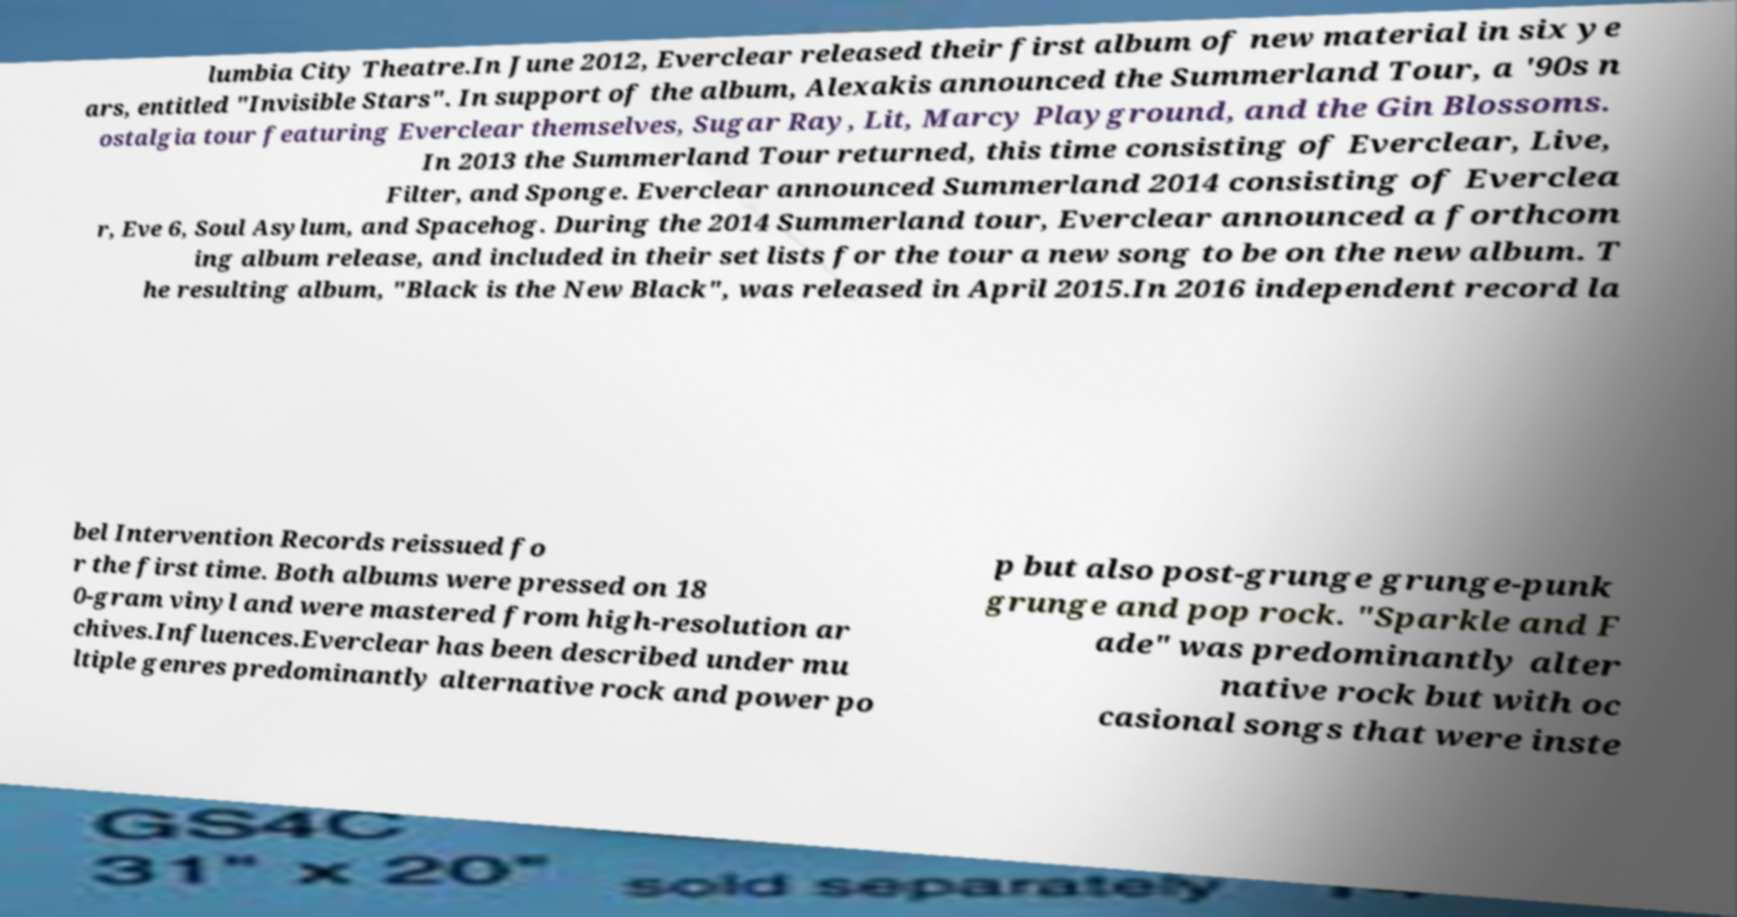For documentation purposes, I need the text within this image transcribed. Could you provide that? lumbia City Theatre.In June 2012, Everclear released their first album of new material in six ye ars, entitled "Invisible Stars". In support of the album, Alexakis announced the Summerland Tour, a '90s n ostalgia tour featuring Everclear themselves, Sugar Ray, Lit, Marcy Playground, and the Gin Blossoms. In 2013 the Summerland Tour returned, this time consisting of Everclear, Live, Filter, and Sponge. Everclear announced Summerland 2014 consisting of Everclea r, Eve 6, Soul Asylum, and Spacehog. During the 2014 Summerland tour, Everclear announced a forthcom ing album release, and included in their set lists for the tour a new song to be on the new album. T he resulting album, "Black is the New Black", was released in April 2015.In 2016 independent record la bel Intervention Records reissued fo r the first time. Both albums were pressed on 18 0-gram vinyl and were mastered from high-resolution ar chives.Influences.Everclear has been described under mu ltiple genres predominantly alternative rock and power po p but also post-grunge grunge-punk grunge and pop rock. "Sparkle and F ade" was predominantly alter native rock but with oc casional songs that were inste 